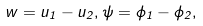Convert formula to latex. <formula><loc_0><loc_0><loc_500><loc_500>w = u _ { 1 } - u _ { 2 } , \psi = \phi _ { 1 } - \phi _ { 2 } ,</formula> 